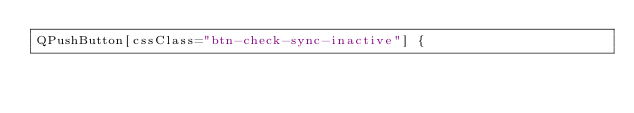<code> <loc_0><loc_0><loc_500><loc_500><_CSS_>QPushButton[cssClass="btn-check-sync-inactive"] {</code> 